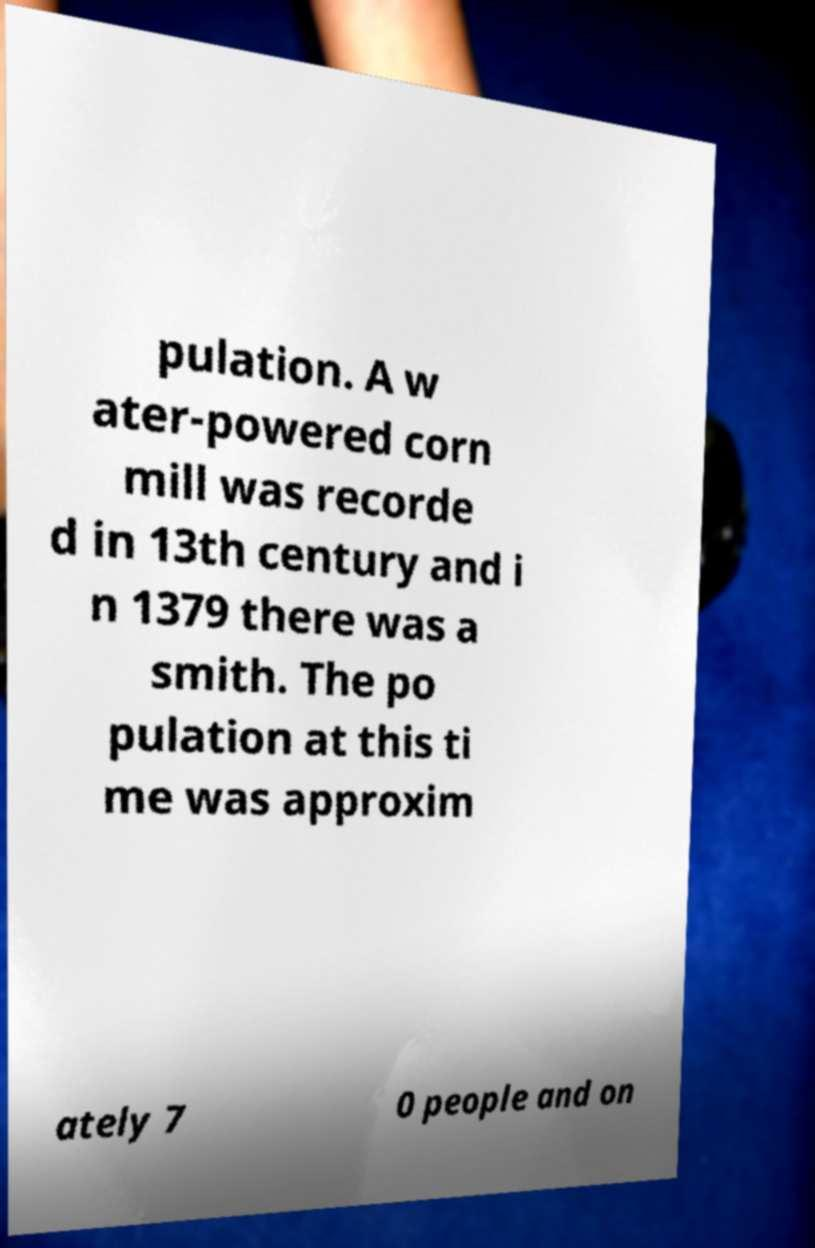For documentation purposes, I need the text within this image transcribed. Could you provide that? pulation. A w ater-powered corn mill was recorde d in 13th century and i n 1379 there was a smith. The po pulation at this ti me was approxim ately 7 0 people and on 